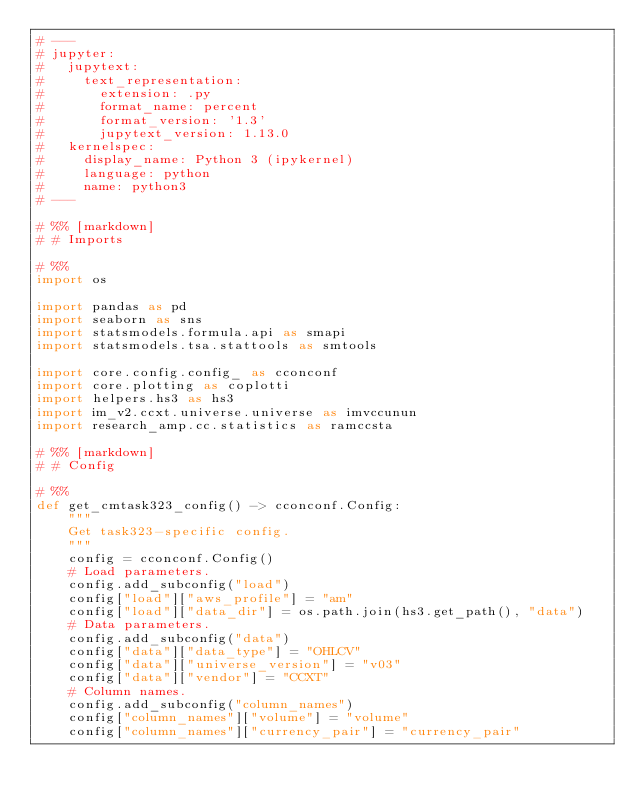<code> <loc_0><loc_0><loc_500><loc_500><_Python_># ---
# jupyter:
#   jupytext:
#     text_representation:
#       extension: .py
#       format_name: percent
#       format_version: '1.3'
#       jupytext_version: 1.13.0
#   kernelspec:
#     display_name: Python 3 (ipykernel)
#     language: python
#     name: python3
# ---

# %% [markdown]
# # Imports

# %%
import os

import pandas as pd
import seaborn as sns
import statsmodels.formula.api as smapi
import statsmodels.tsa.stattools as smtools

import core.config.config_ as cconconf
import core.plotting as coplotti
import helpers.hs3 as hs3
import im_v2.ccxt.universe.universe as imvccunun
import research_amp.cc.statistics as ramccsta

# %% [markdown]
# # Config

# %%
def get_cmtask323_config() -> cconconf.Config:
    """
    Get task323-specific config.
    """
    config = cconconf.Config()
    # Load parameters.
    config.add_subconfig("load")
    config["load"]["aws_profile"] = "am"
    config["load"]["data_dir"] = os.path.join(hs3.get_path(), "data")
    # Data parameters.
    config.add_subconfig("data")
    config["data"]["data_type"] = "OHLCV"
    config["data"]["universe_version"] = "v03"
    config["data"]["vendor"] = "CCXT"
    # Column names.
    config.add_subconfig("column_names")
    config["column_names"]["volume"] = "volume"
    config["column_names"]["currency_pair"] = "currency_pair"</code> 